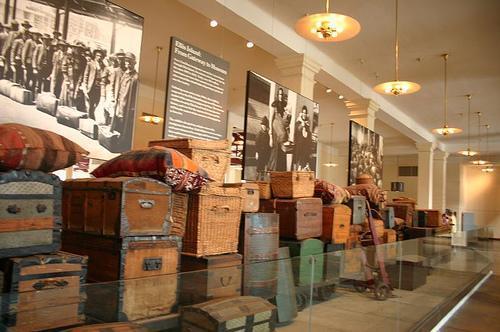How many hanging lights are there?
Give a very brief answer. 6. How many suitcases are in the picture?
Give a very brief answer. 8. 